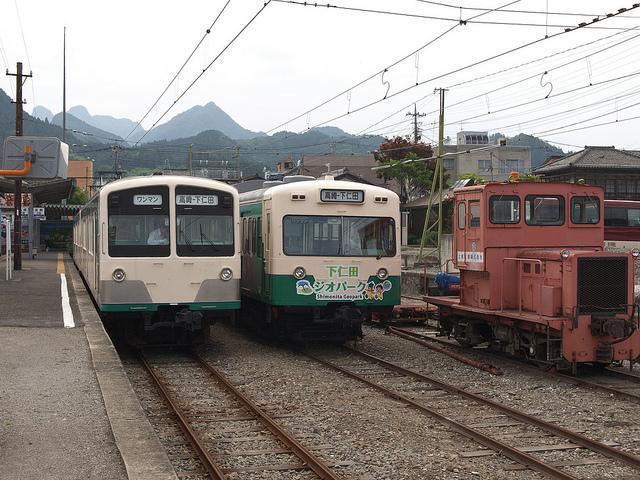How many trains are in the image?
Give a very brief answer. 2. How many trains can you see?
Give a very brief answer. 3. How many cars are in this picture?
Give a very brief answer. 0. 